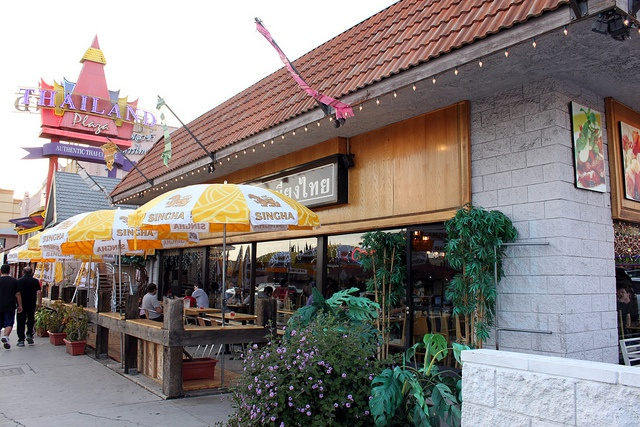Describe the objects in this image and their specific colors. I can see potted plant in white, black, gray, and darkgreen tones, umbrella in white, lightgray, khaki, gold, and darkgray tones, potted plant in white, black, teal, and darkgreen tones, potted plant in white, black, teal, darkgreen, and gray tones, and umbrella in white, lavender, khaki, darkgray, and red tones in this image. 